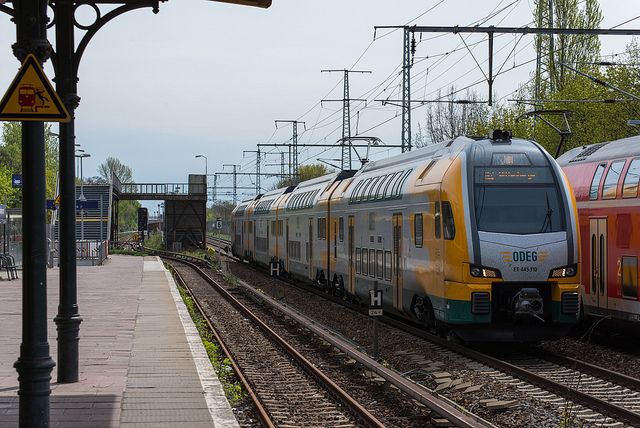Identify and read out the text in this image. 0DEG 2 